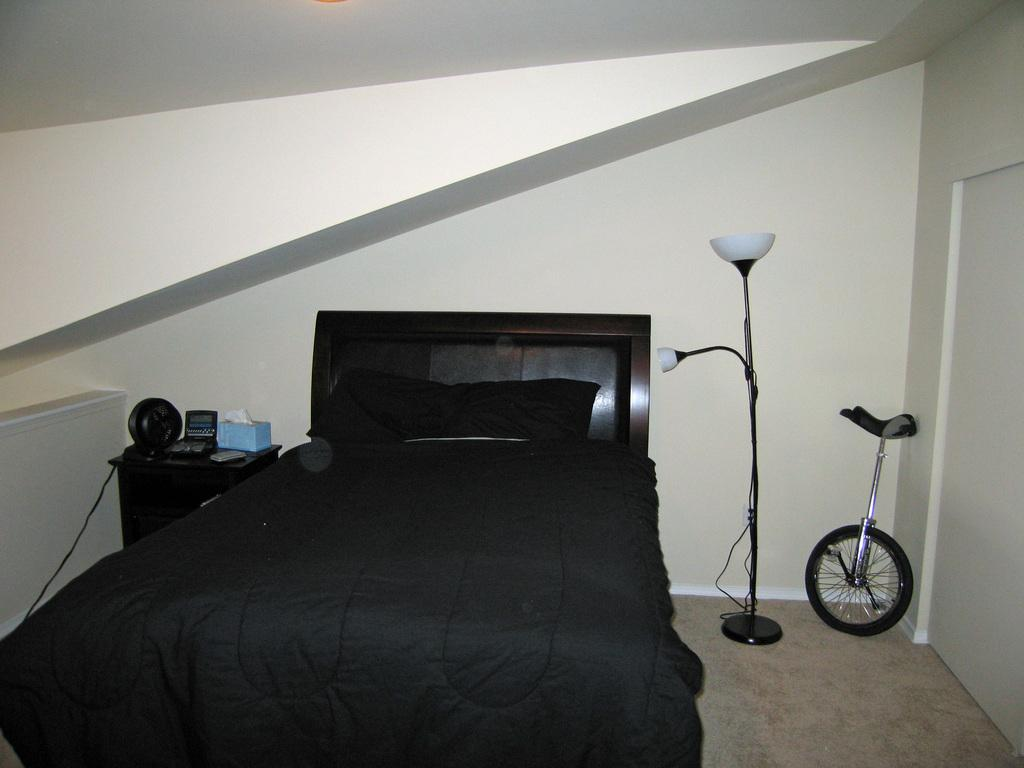What type of furniture is present in the image? There is a bed in the image. What is the source of light in the image? There is a lamp in the image. What can be seen behind the bed and lamp? There is a wall in the image. Can you see a giraffe standing on the bed in the image? No, there is no giraffe present in the image. What type of apparatus is used to stretch the wall in the image? There is no apparatus or stretching action depicted in the image; the wall is stationary. 